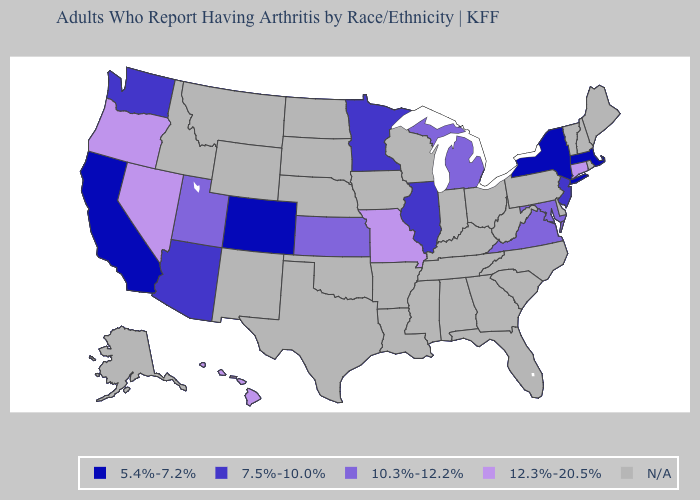Name the states that have a value in the range 10.3%-12.2%?
Quick response, please. Kansas, Maryland, Michigan, Utah, Virginia. Does Oregon have the highest value in the West?
Quick response, please. Yes. Name the states that have a value in the range N/A?
Be succinct. Alabama, Alaska, Arkansas, Delaware, Florida, Georgia, Idaho, Indiana, Iowa, Kentucky, Louisiana, Maine, Mississippi, Montana, Nebraska, New Hampshire, New Mexico, North Carolina, North Dakota, Ohio, Oklahoma, Pennsylvania, Rhode Island, South Carolina, South Dakota, Tennessee, Texas, Vermont, West Virginia, Wisconsin, Wyoming. What is the value of Kansas?
Keep it brief. 10.3%-12.2%. What is the highest value in states that border Ohio?
Be succinct. 10.3%-12.2%. What is the highest value in the MidWest ?
Be succinct. 12.3%-20.5%. Among the states that border Kansas , does Missouri have the highest value?
Short answer required. Yes. Which states have the lowest value in the Northeast?
Write a very short answer. Massachusetts, New York. Does Connecticut have the highest value in the USA?
Quick response, please. Yes. Name the states that have a value in the range 10.3%-12.2%?
Quick response, please. Kansas, Maryland, Michigan, Utah, Virginia. Name the states that have a value in the range 5.4%-7.2%?
Keep it brief. California, Colorado, Massachusetts, New York. Which states have the lowest value in the West?
Be succinct. California, Colorado. What is the value of Virginia?
Be succinct. 10.3%-12.2%. What is the value of Rhode Island?
Give a very brief answer. N/A. What is the value of North Dakota?
Answer briefly. N/A. 